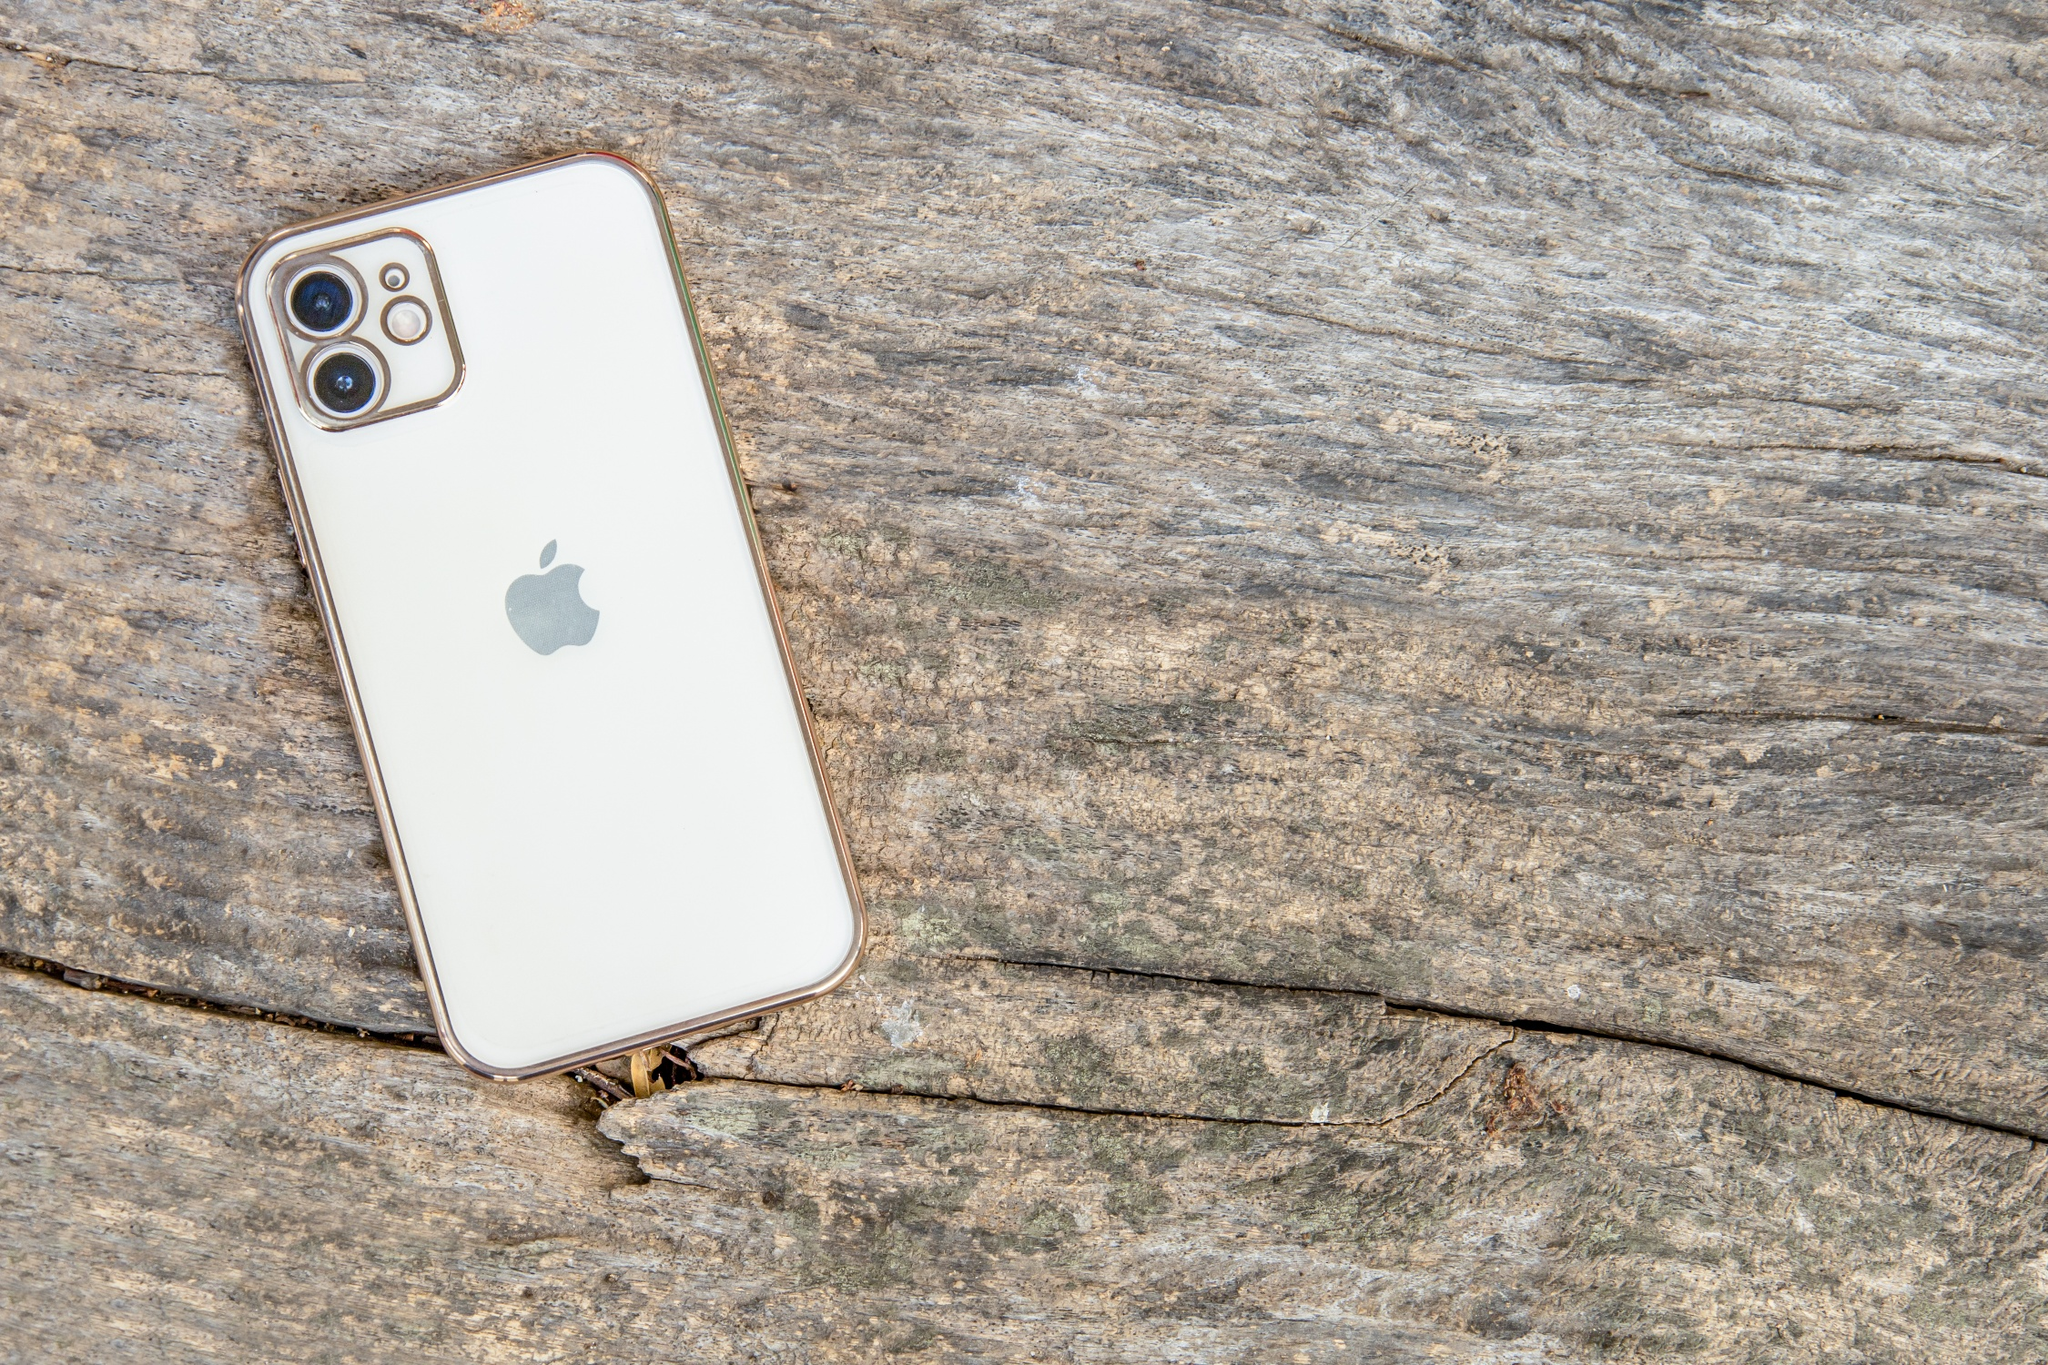Imagine a story behind how the phone ended up on the cracked wooden surface. In a quaint countryside cottage, nestled between rolling hills, lived an artist named Eli. Eli often took long walks through the surrounding woods, seeking inspiration for his next masterpiece. One crisp autumn morning, he ventured deeper into the forest than ever before, discovering an old wooden bench, weathered by countless seasons. It was here that he decided to spend some time sketching the serene landscape. Engrossed in his work, Eli placed his white iPhone on the bench, capturing the moment with a photo of the tranquil scenery as a reference for his painting. Lost in the beauty of nature, he eventually forgot the phone, leaving it to become a silent witness to the passage of time, merging modern technology with the rustic charm of the woods. 